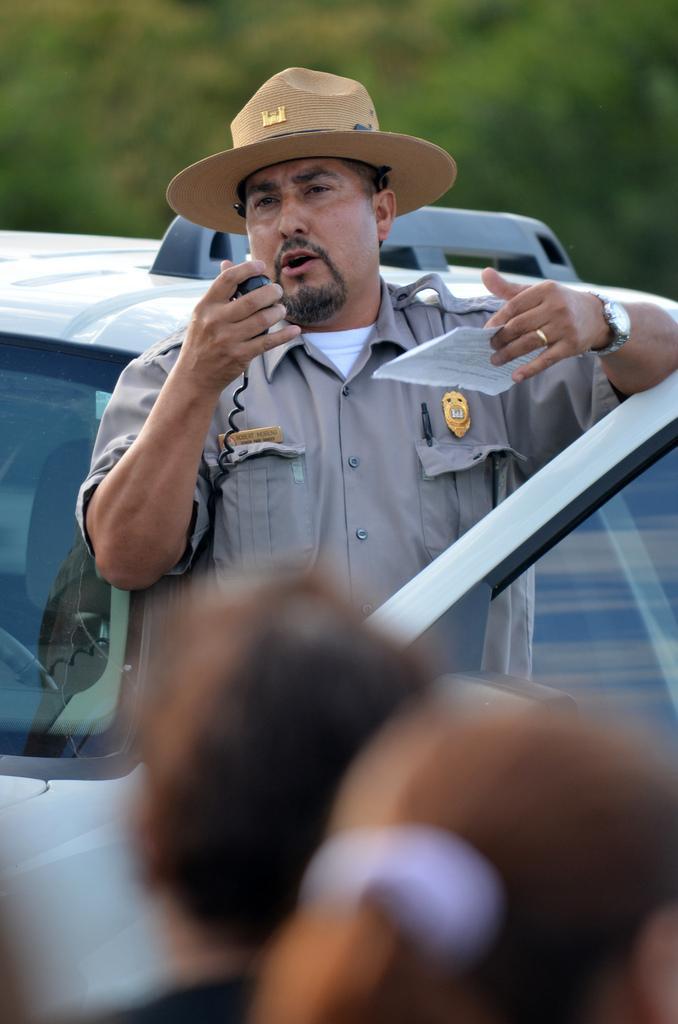Could you give a brief overview of what you see in this image? In this picture there are people, among them there's a man holding a paper and device and we can see vehicle. In the background of the image it is blurry. 